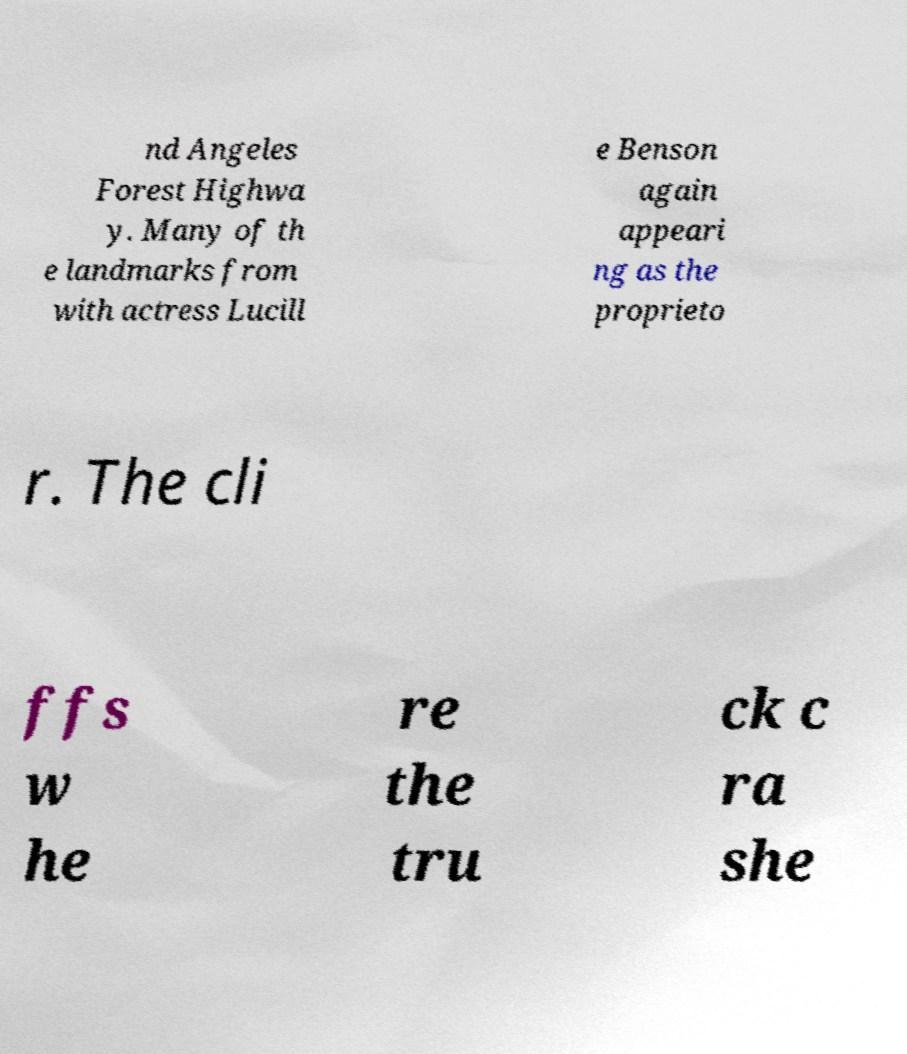For documentation purposes, I need the text within this image transcribed. Could you provide that? nd Angeles Forest Highwa y. Many of th e landmarks from with actress Lucill e Benson again appeari ng as the proprieto r. The cli ffs w he re the tru ck c ra she 